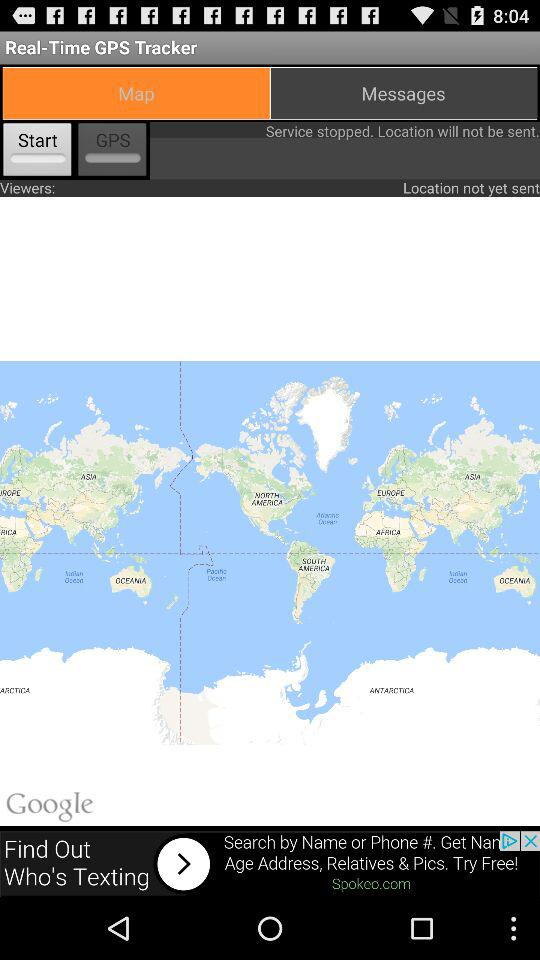What is the application name? The application name is "Real-Time GPS Tracker". 